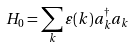Convert formula to latex. <formula><loc_0><loc_0><loc_500><loc_500>H _ { 0 } = \sum _ { k } \varepsilon ( k ) a _ { k } ^ { \dagger } a _ { k }</formula> 